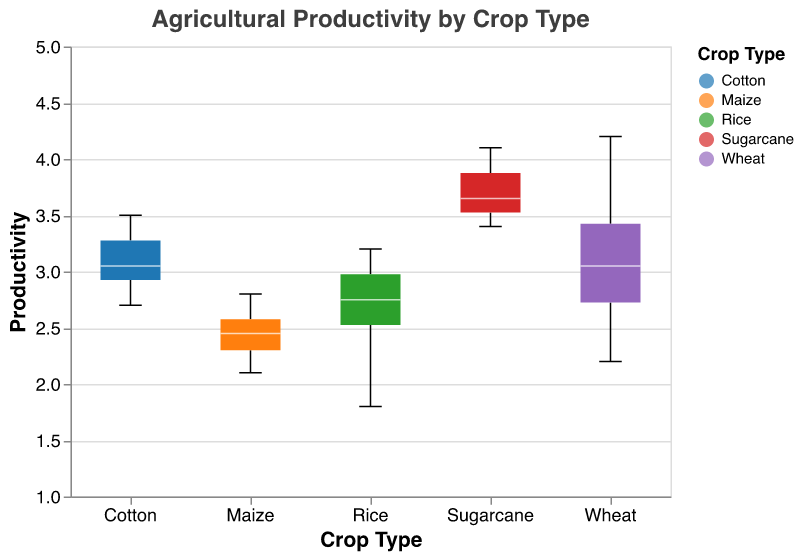What is the title of the plot? The title of the plot can be seen at the top of the figure in a larger font size than the rest of the text.
Answer: Agricultural Productivity by Crop Type How is the productivity of Sugarcane for Tamil Nadu depicted in the plot? Look at the box plot for Sugarcane and identify the position of Tamil Nadu within the notched box plot for Sugarcane.
Answer: 4.1 Which crop type exhibits the highest median productivity? The median productivity is represented by the white line inside each notched box. Compare the white lines across all crop types.
Answer: Wheat Compare the range of productivity for Rice and Maize. Which has a wider range? The range is the distance between the minimum and maximum values shown by the whiskers of the box plots. Compare the lengths of the whiskers for Rice and Maize.
Answer: Rice Which state has the lowest productivity for Wheat? Check the minimum value of the notched box plot for Wheat by looking at the bottom whisker. Find which state corresponds to that value.
Answer: Maharashtra What is the interquartile range (IQR) for Cotton? The IQR is the distance between the 25th percentile (bottom of the box) and the 75th percentile (top of the box) in the notched box plot. Examine the box section for Cotton.
Answer: 3.1 to 3.4 Is there any state that is an outlier in the productivity of Maize? Outliers are typically marked with individual points beyond the whiskers of the box plot. Check for any outliers in the Maize box plot.
Answer: No Which crop type has the smallest notched area indicating the narrowest confidence interval around the median? The notched area represents the confidence interval for the median. The smaller the notched area, the narrower the confidence interval. Compare the notches for all crop types.
Answer: Maize By how much does the maximum productivity of Sugarcane exceed the minimum productivity of Cotton? Identify the maximum value for Sugarcane and the minimum value for Cotton from the whiskers of their respective box plots. Subtract the minimum value of Cotton from the maximum value of Sugarcane.
Answer: 4.1 - 2.7 = 1.4 